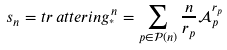Convert formula to latex. <formula><loc_0><loc_0><loc_500><loc_500>s _ { n } = t r \, a t t e r i n g _ { ^ { * } } ^ { n } = \sum _ { p \in \mathcal { P } ( n ) } \frac { n } { r _ { p } } \mathcal { A } _ { p } ^ { r _ { p } }</formula> 